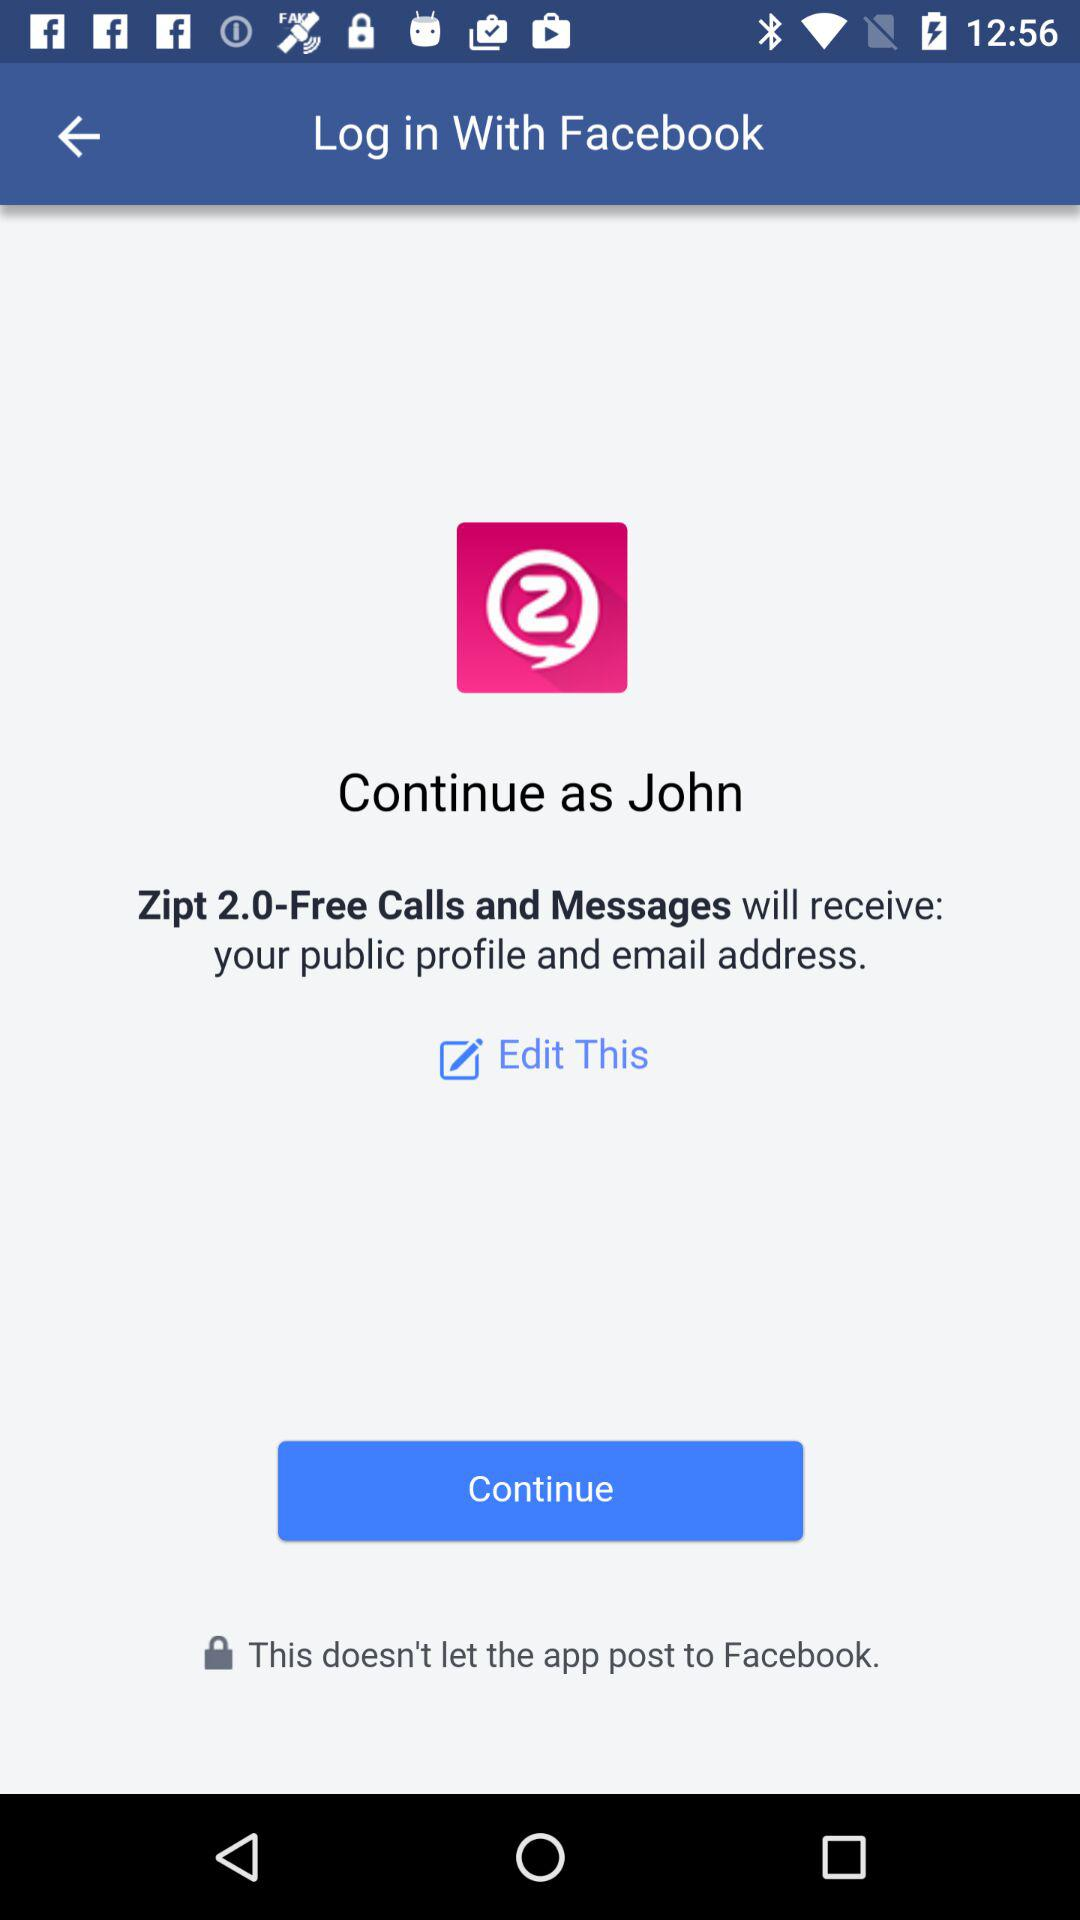What applications can be used to log in to the profile? The application "Facebook" can be used to log in to the profile. 